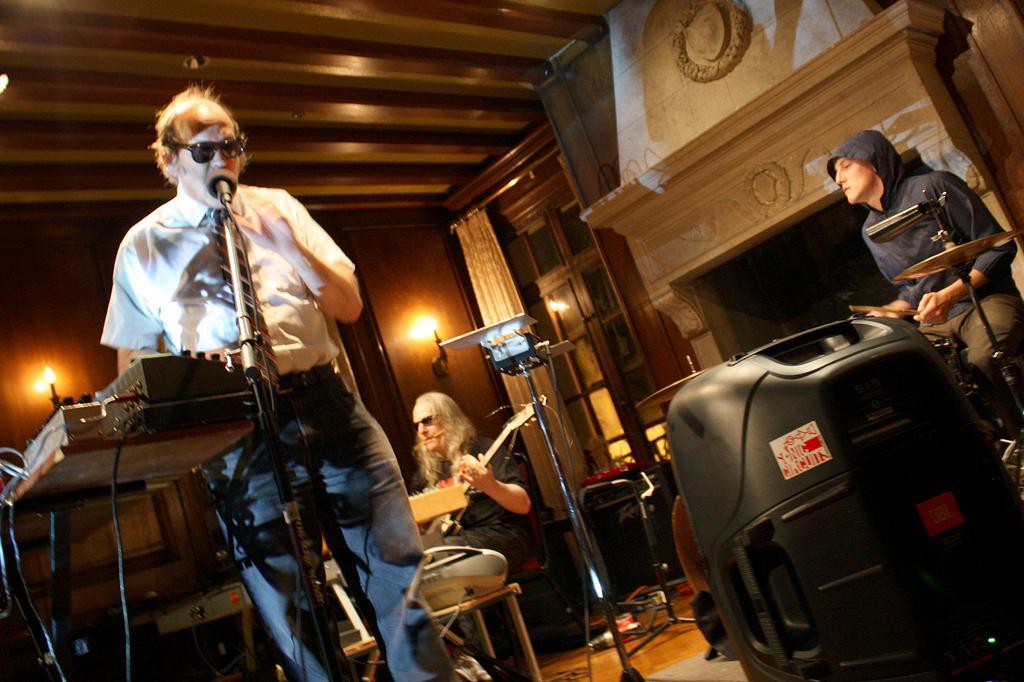Describe this image in one or two sentences. In this image I can see three persons. In front the person is standing and I can also see the microphone. In the background I can see two persons playing few musical instruments and I can also see few lights and the wall is in brown color. 